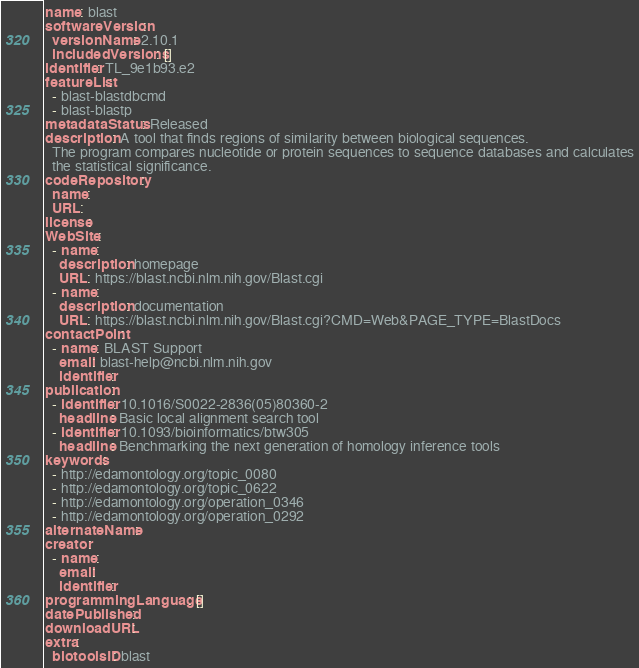<code> <loc_0><loc_0><loc_500><loc_500><_YAML_>name: blast
softwareVersion:
  versionName: 2.10.1
  includedVersions: []
identifier: TL_9e1b93.e2
featureList:
  - blast-blastdbcmd
  - blast-blastp
metadataStatus: Released
description: A tool that finds regions of similarity between biological sequences.
  The program compares nucleotide or protein sequences to sequence databases and calculates
  the statistical significance.
codeRepository:
  name:
  URL:
license:
WebSite:
  - name:
    description: homepage
    URL: https://blast.ncbi.nlm.nih.gov/Blast.cgi
  - name:
    description: documentation
    URL: https://blast.ncbi.nlm.nih.gov/Blast.cgi?CMD=Web&PAGE_TYPE=BlastDocs
contactPoint:
  - name: BLAST Support
    email: blast-help@ncbi.nlm.nih.gov
    identifier:
publication:
  - identifier: 10.1016/S0022-2836(05)80360-2
    headline: Basic local alignment search tool
  - identifier: 10.1093/bioinformatics/btw305
    headline: Benchmarking the next generation of homology inference tools
keywords:
  - http://edamontology.org/topic_0080
  - http://edamontology.org/topic_0622
  - http://edamontology.org/operation_0346
  - http://edamontology.org/operation_0292
alternateName:
creator:
  - name:
    email:
    identifier:
programmingLanguage: []
datePublished:
downloadURL:
extra:
  biotoolsID: blast
</code> 